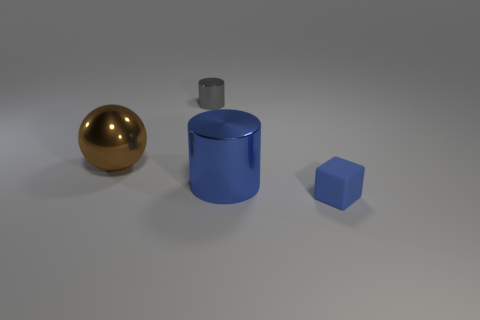Add 4 big green shiny blocks. How many objects exist? 8 Subtract all cubes. How many objects are left? 3 Add 3 brown objects. How many brown objects are left? 4 Add 1 yellow rubber objects. How many yellow rubber objects exist? 1 Subtract 1 blue cylinders. How many objects are left? 3 Subtract all big red metal things. Subtract all metallic cylinders. How many objects are left? 2 